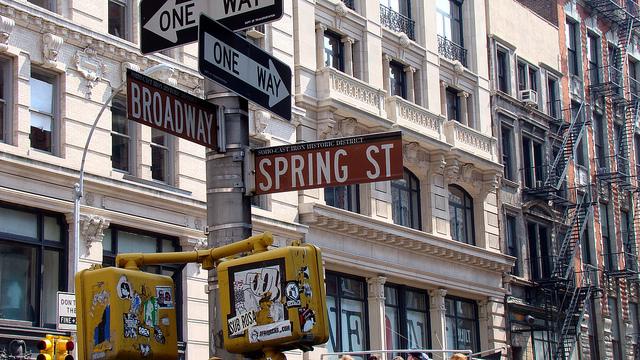What does the arrow say?
Give a very brief answer. One way. What corner is this picture taken at?
Write a very short answer. Spring and broadway. How many Brown Street signs do you see?
Short answer required. 2. Which way is one way?
Be succinct. Broadway. How many signs are there?
Be succinct. 4. Are all the signs intact?
Quick response, please. Yes. 